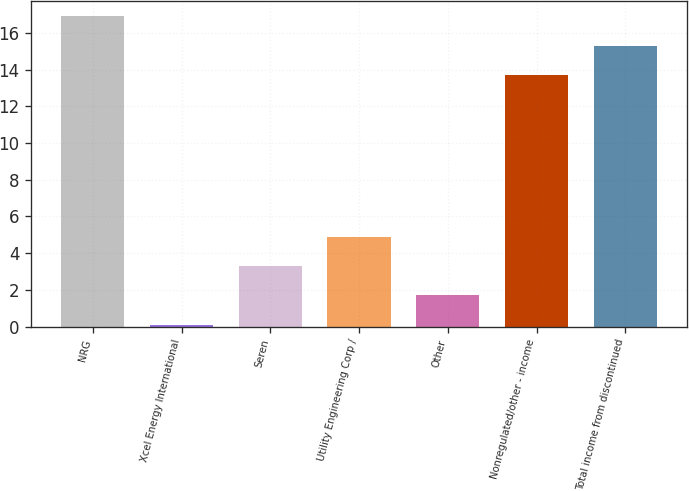Convert chart to OTSL. <chart><loc_0><loc_0><loc_500><loc_500><bar_chart><fcel>NRG<fcel>Xcel Energy International<fcel>Seren<fcel>Utility Engineering Corp /<fcel>Other<fcel>Nonregulated/other - income<fcel>Total income from discontinued<nl><fcel>16.9<fcel>0.1<fcel>3.3<fcel>4.9<fcel>1.7<fcel>13.7<fcel>15.3<nl></chart> 